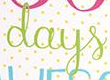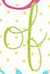What text is displayed in these images sequentially, separated by a semicolon? days; of 